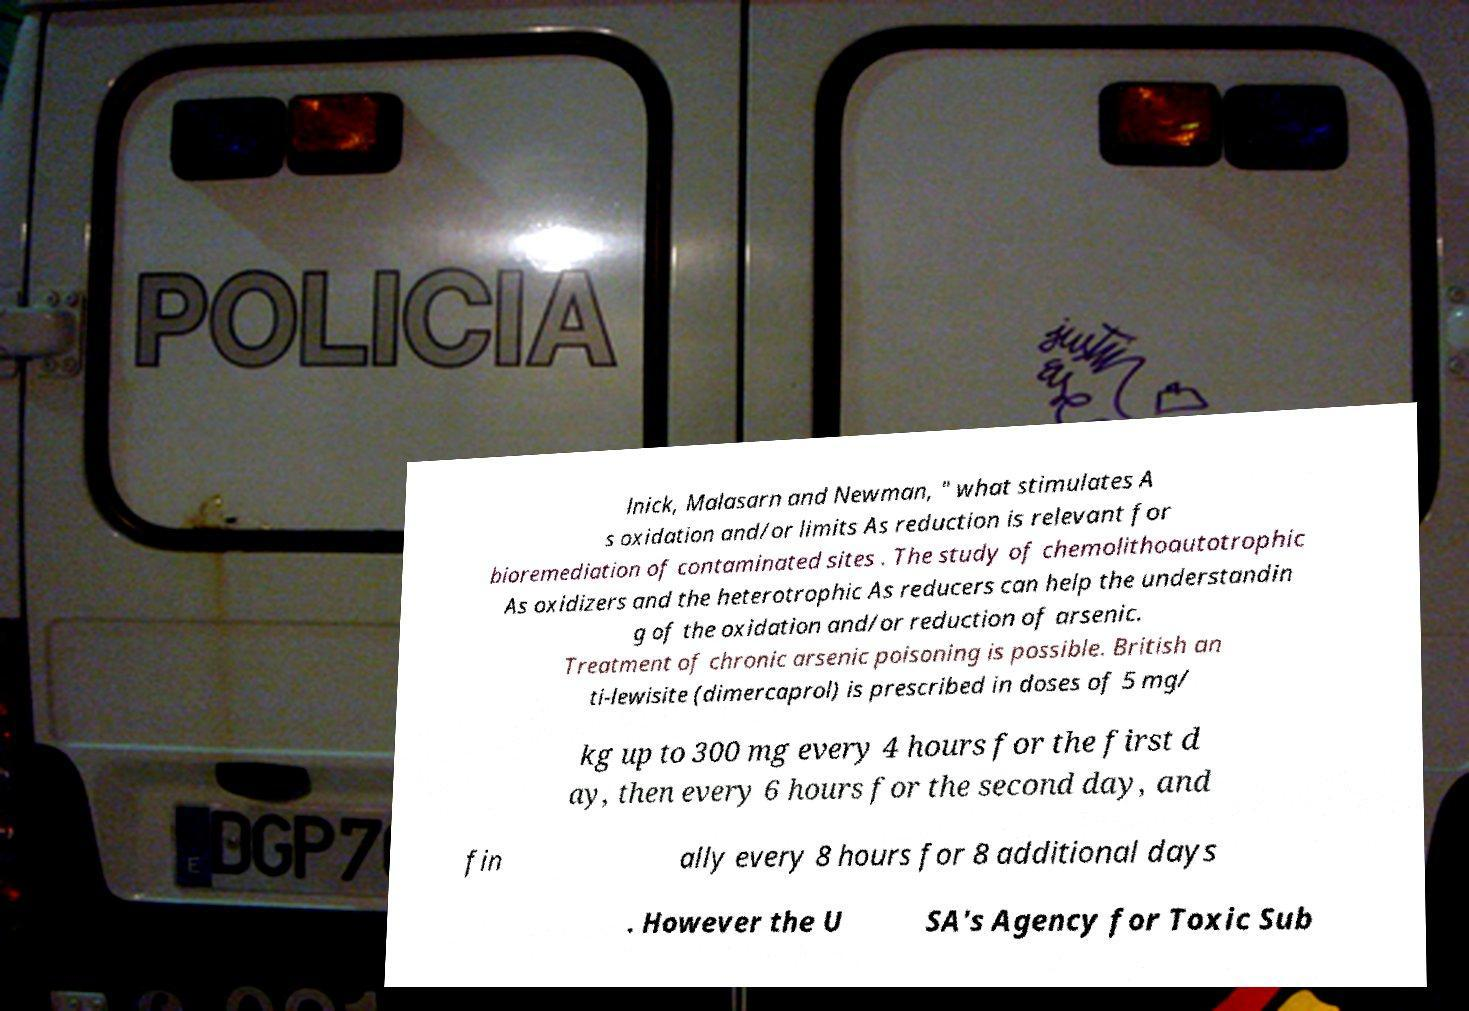What messages or text are displayed in this image? I need them in a readable, typed format. lnick, Malasarn and Newman, " what stimulates A s oxidation and/or limits As reduction is relevant for bioremediation of contaminated sites . The study of chemolithoautotrophic As oxidizers and the heterotrophic As reducers can help the understandin g of the oxidation and/or reduction of arsenic. Treatment of chronic arsenic poisoning is possible. British an ti-lewisite (dimercaprol) is prescribed in doses of 5 mg/ kg up to 300 mg every 4 hours for the first d ay, then every 6 hours for the second day, and fin ally every 8 hours for 8 additional days . However the U SA's Agency for Toxic Sub 